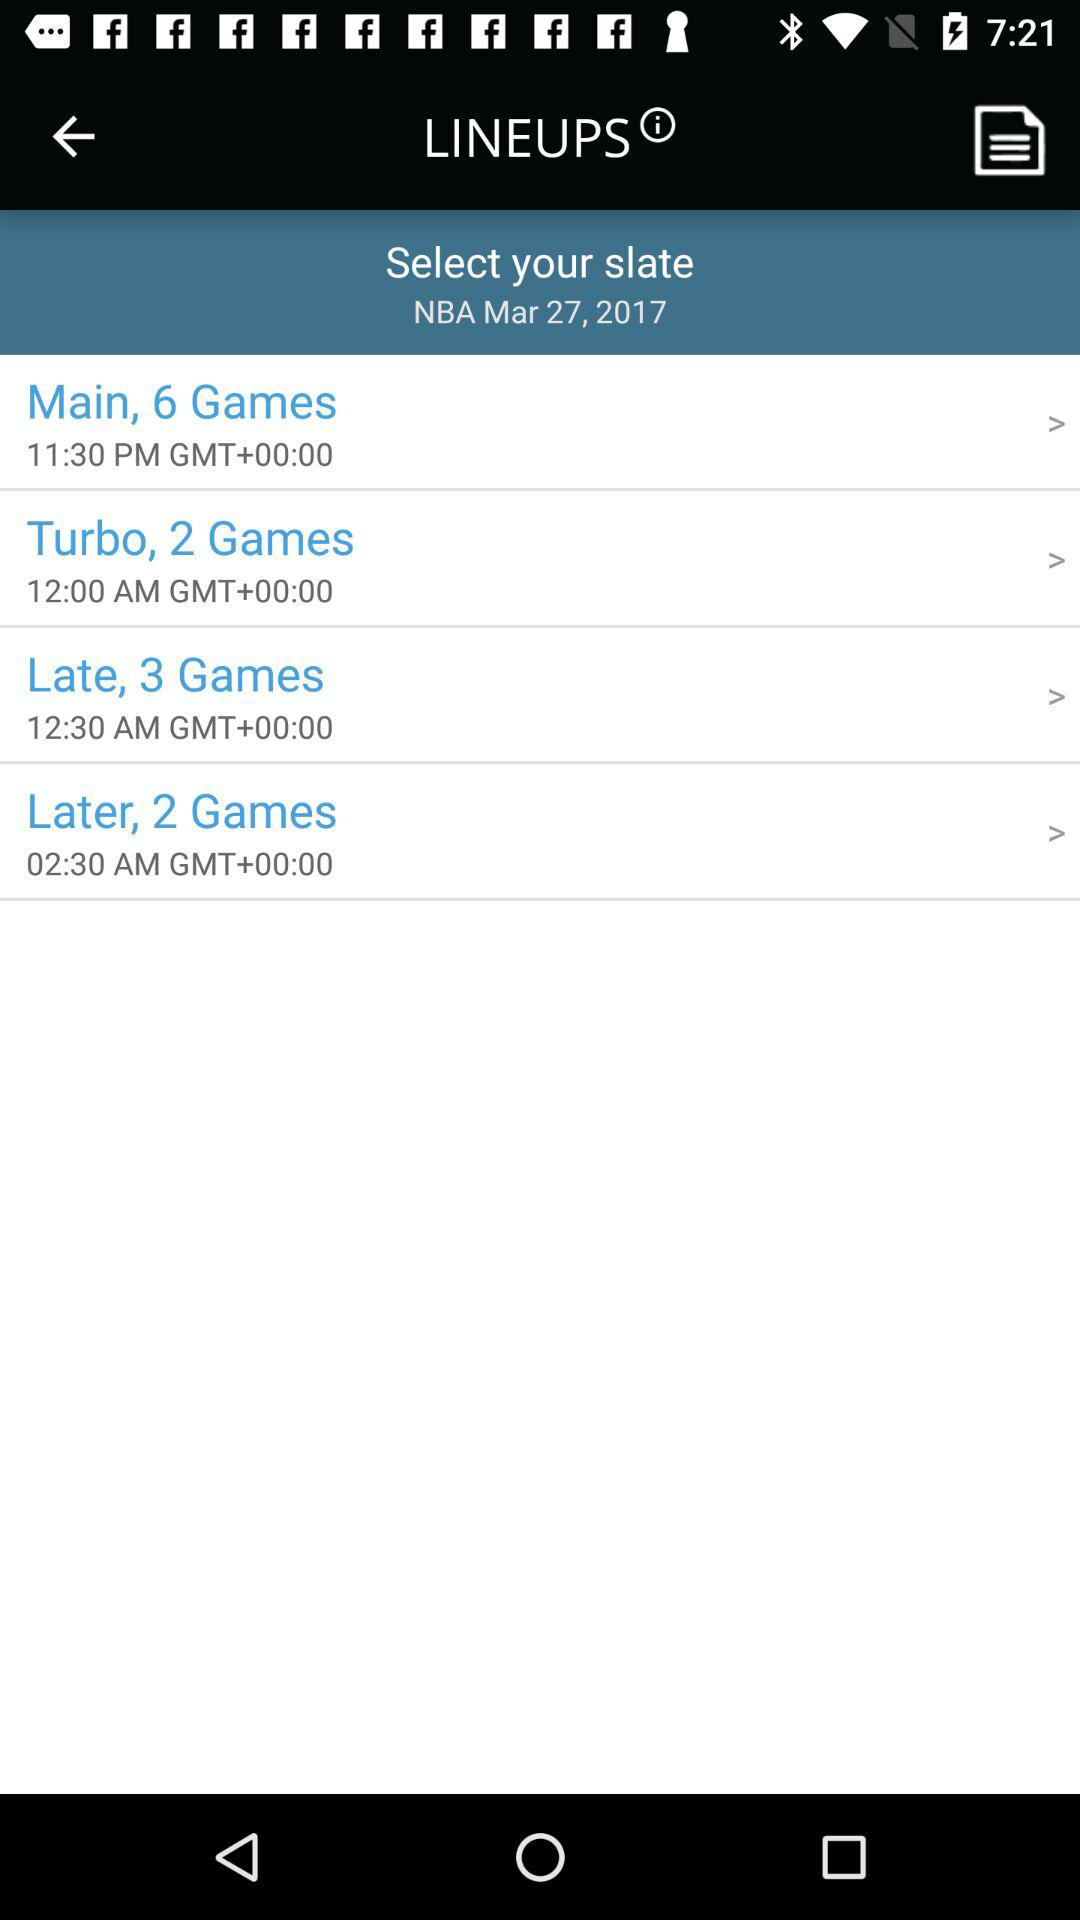What is the time for "Main, 6 Games"? The time is 11:30 p.m. GMT +00.00. 